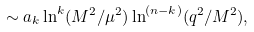Convert formula to latex. <formula><loc_0><loc_0><loc_500><loc_500>\sim a _ { k } \ln ^ { k } ( M ^ { 2 } / \mu ^ { 2 } ) \ln ^ { ( n - k ) } ( q ^ { 2 } / M ^ { 2 } ) ,</formula> 